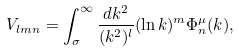Convert formula to latex. <formula><loc_0><loc_0><loc_500><loc_500>V _ { l m n } = \int _ { \sigma } ^ { \infty } \frac { d k ^ { 2 } } { ( k ^ { 2 } ) ^ { l } } ( \ln k ) ^ { m } \Phi _ { n } ^ { \mu } ( k ) ,</formula> 